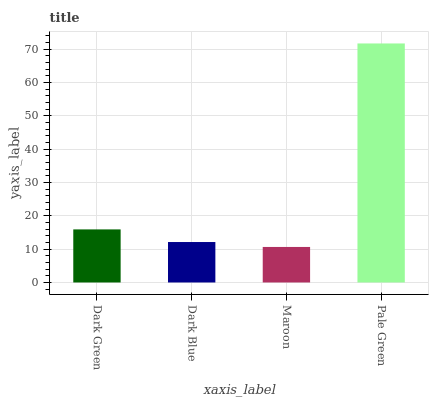Is Maroon the minimum?
Answer yes or no. Yes. Is Pale Green the maximum?
Answer yes or no. Yes. Is Dark Blue the minimum?
Answer yes or no. No. Is Dark Blue the maximum?
Answer yes or no. No. Is Dark Green greater than Dark Blue?
Answer yes or no. Yes. Is Dark Blue less than Dark Green?
Answer yes or no. Yes. Is Dark Blue greater than Dark Green?
Answer yes or no. No. Is Dark Green less than Dark Blue?
Answer yes or no. No. Is Dark Green the high median?
Answer yes or no. Yes. Is Dark Blue the low median?
Answer yes or no. Yes. Is Maroon the high median?
Answer yes or no. No. Is Dark Green the low median?
Answer yes or no. No. 